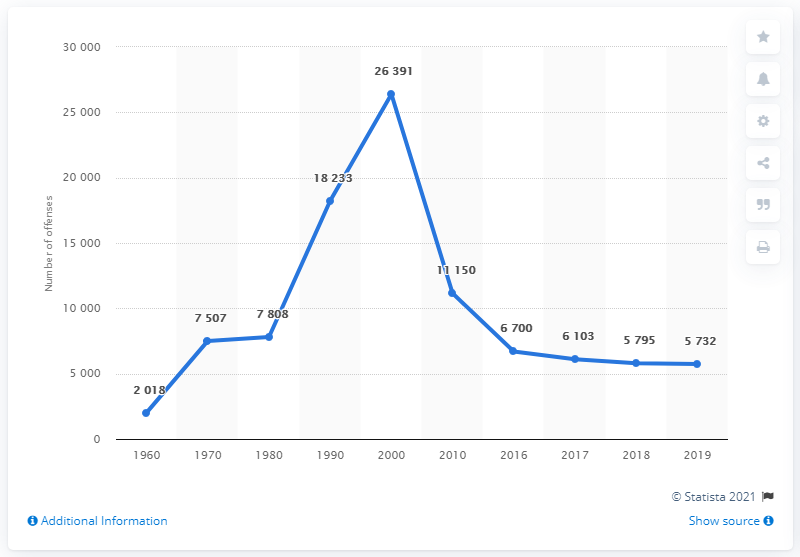Identify some key points in this picture. The highest peak number on the chart is 26,391. The sum of production between the years 1960 and 2018, including 2019, is 13,545. In 2000, the number of car thefts recorded by the police increased. 